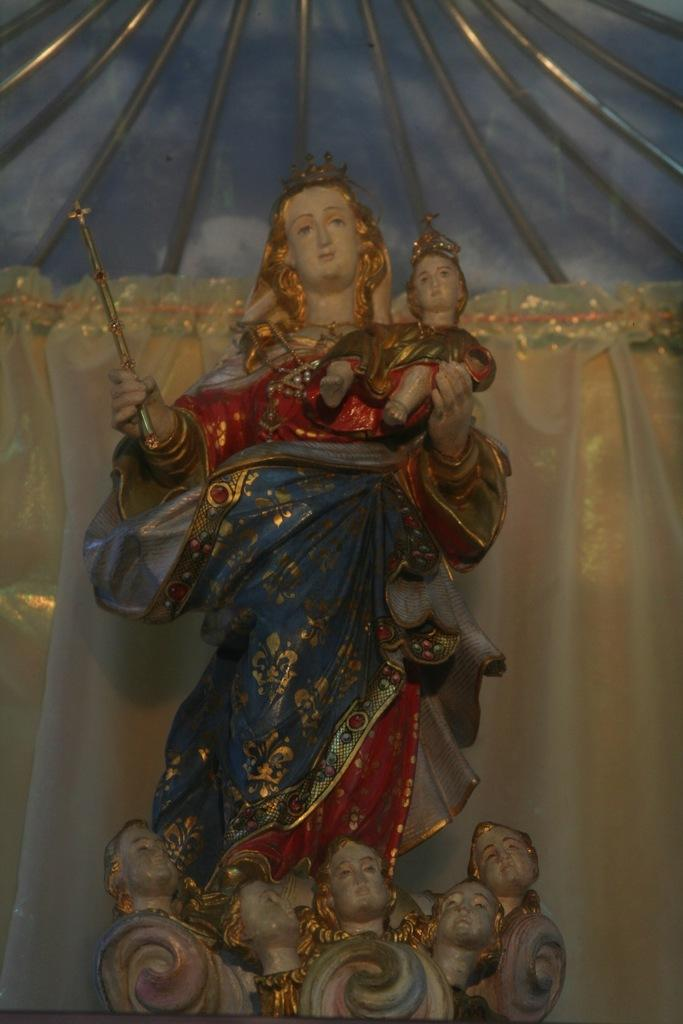What is the main subject of the image? The main subject of the image is idols. Can you describe the appearance of the idols? The idols are wearing colorful clothes. What else can be seen at the top of the image? There are rods visible at the top of the image. Can you tell me how many pears are being used in the argument between the idols in the image? There are no pears or arguments present in the image; it features idols wearing colorful clothes and rods at the top. What level of experience does the beginner idol have in the image? There is no mention of a beginner idol or any levels of experience in the image. 